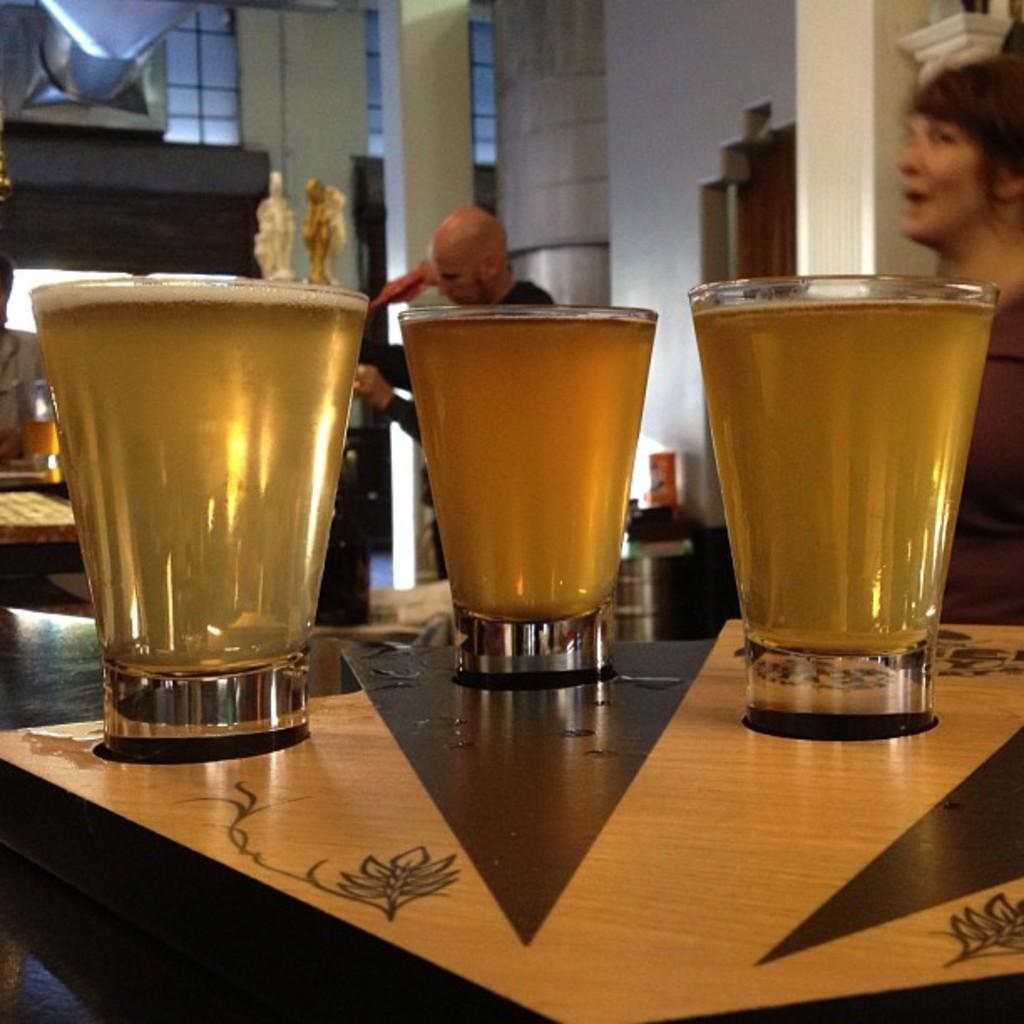How many glasses are on the table in the image? There are three glasses on the table in the image. What can be seen in the background of the image? There is a building visible in the background of the image. What type of agreement was reached between the glasses in the image? There is no indication in the image that the glasses have reached any agreement, as they are inanimate objects. 